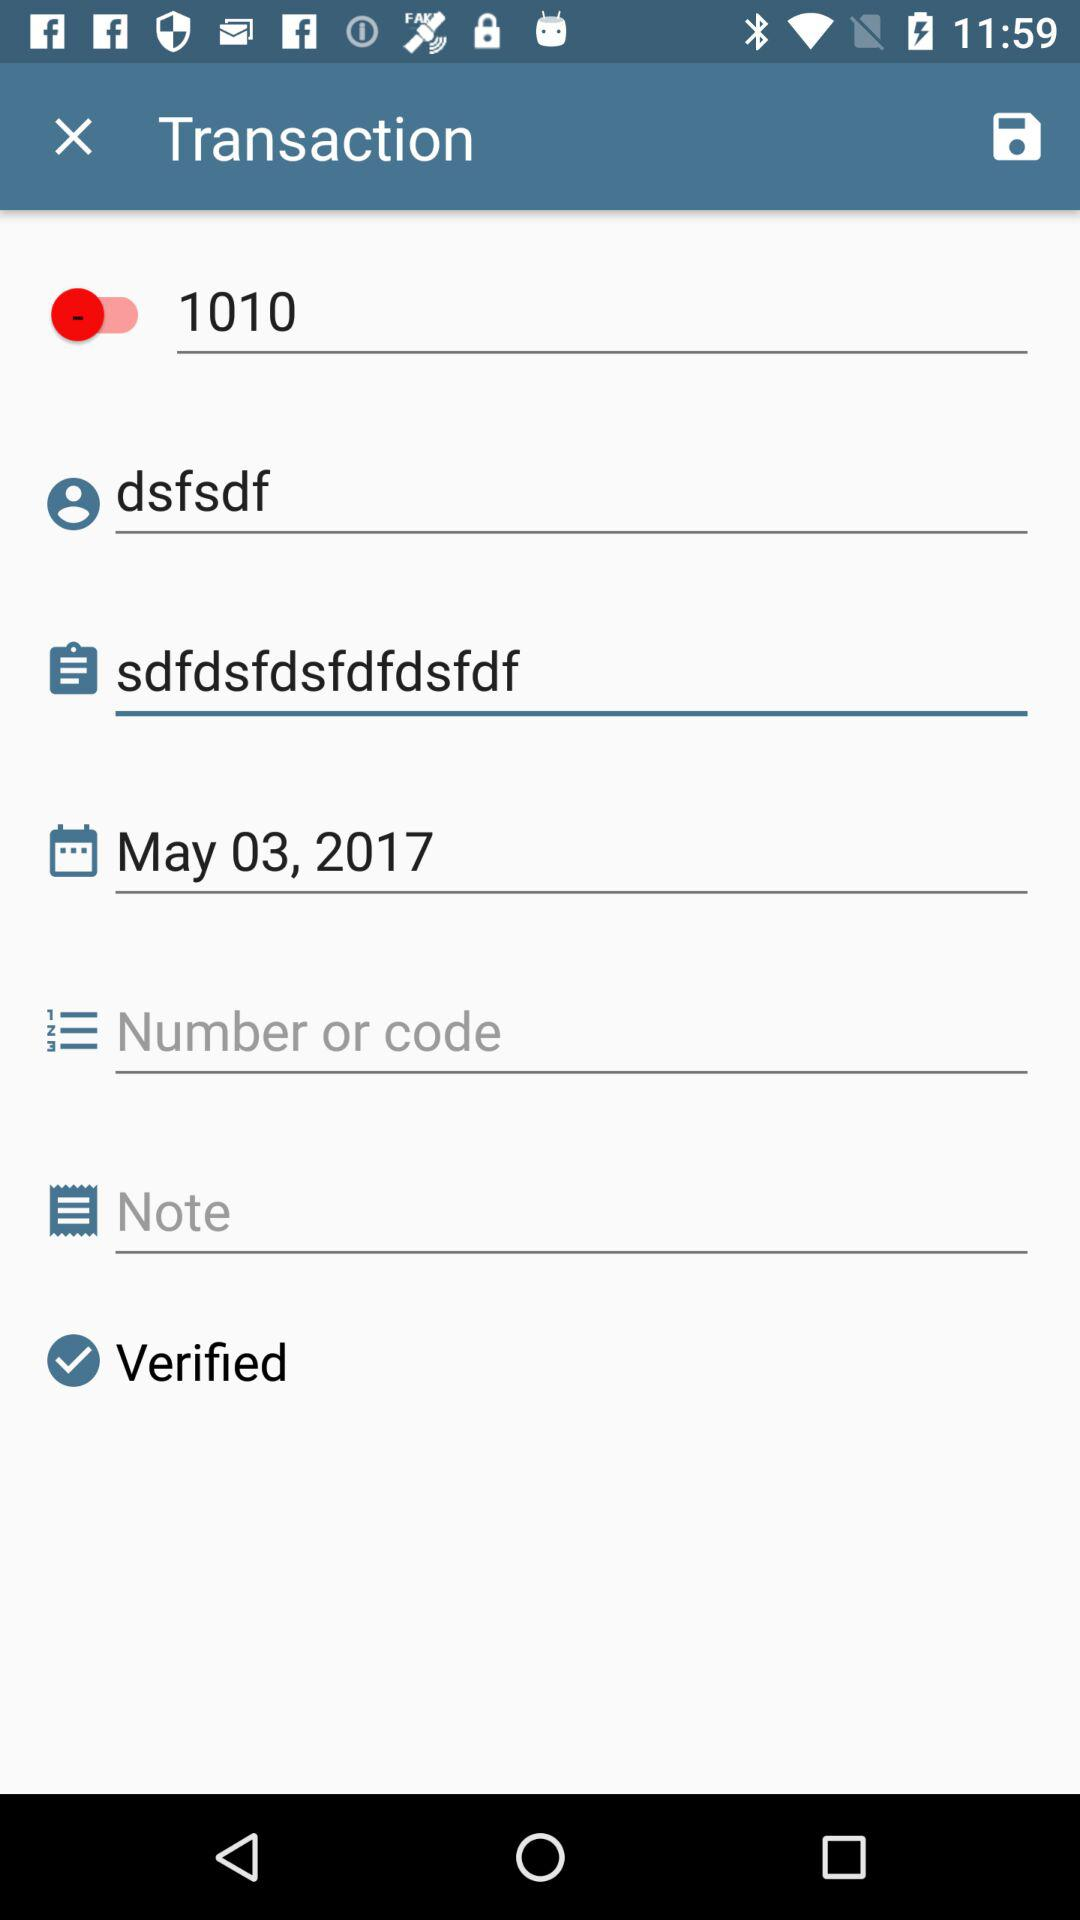What is the username? The username is "dsfsdf". 